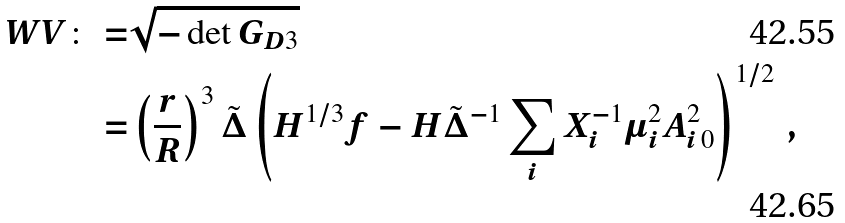<formula> <loc_0><loc_0><loc_500><loc_500>W V \colon = & \sqrt { - \det G _ { D 3 } } \\ = & \left ( \frac { r } { R } \right ) ^ { 3 } \tilde { \Delta } \left ( H ^ { 1 / 3 } f - H \tilde { \Delta } ^ { - 1 } \sum _ { i } X _ { i } ^ { - 1 } \mu _ { i } ^ { 2 } A _ { i \, 0 } ^ { 2 } \right ) ^ { 1 / 2 } \, ,</formula> 